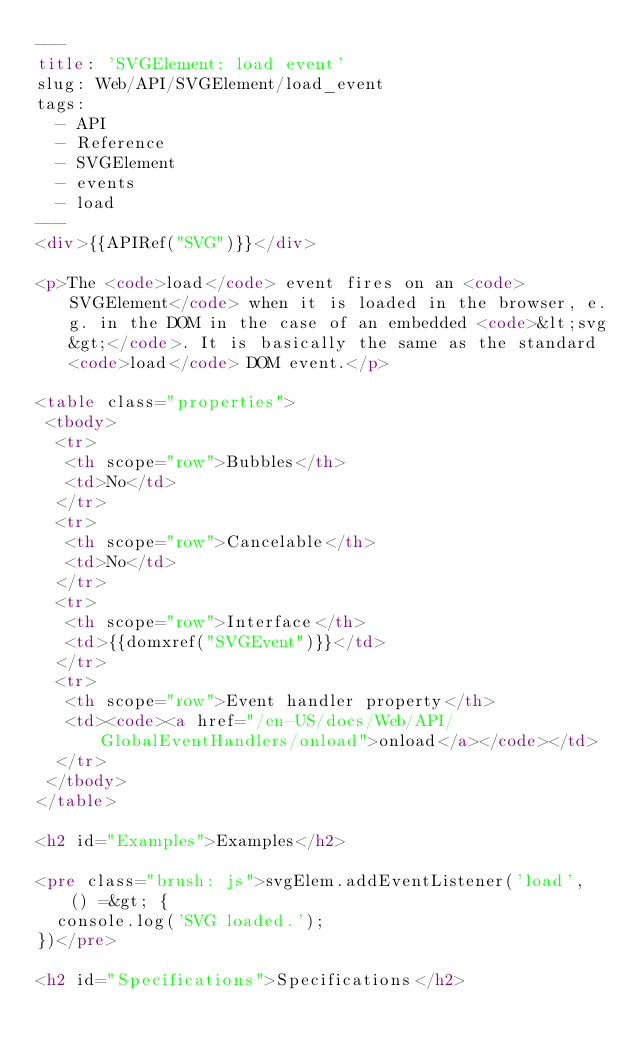<code> <loc_0><loc_0><loc_500><loc_500><_HTML_>---
title: 'SVGElement: load event'
slug: Web/API/SVGElement/load_event
tags:
  - API
  - Reference
  - SVGElement
  - events
  - load
---
<div>{{APIRef("SVG")}}</div>

<p>The <code>load</code> event fires on an <code>SVGElement</code> when it is loaded in the browser, e.g. in the DOM in the case of an embedded <code>&lt;svg&gt;</code>. It is basically the same as the standard <code>load</code> DOM event.</p>

<table class="properties">
 <tbody>
  <tr>
   <th scope="row">Bubbles</th>
   <td>No</td>
  </tr>
  <tr>
   <th scope="row">Cancelable</th>
   <td>No</td>
  </tr>
  <tr>
   <th scope="row">Interface</th>
   <td>{{domxref("SVGEvent")}}</td>
  </tr>
  <tr>
   <th scope="row">Event handler property</th>
   <td><code><a href="/en-US/docs/Web/API/GlobalEventHandlers/onload">onload</a></code></td>
  </tr>
 </tbody>
</table>

<h2 id="Examples">Examples</h2>

<pre class="brush: js">svgElem.addEventListener('load', () =&gt; {
  console.log('SVG loaded.');
})</pre>

<h2 id="Specifications">Specifications</h2>
</code> 